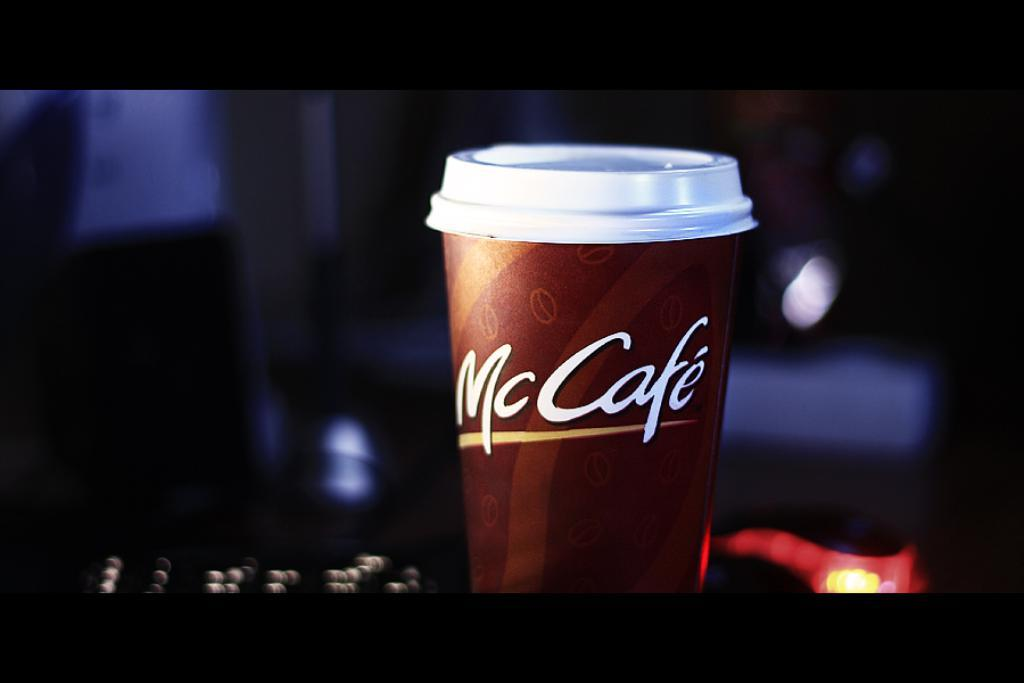<image>
Provide a brief description of the given image. A cup of coffee from the McCafe is by itself. 